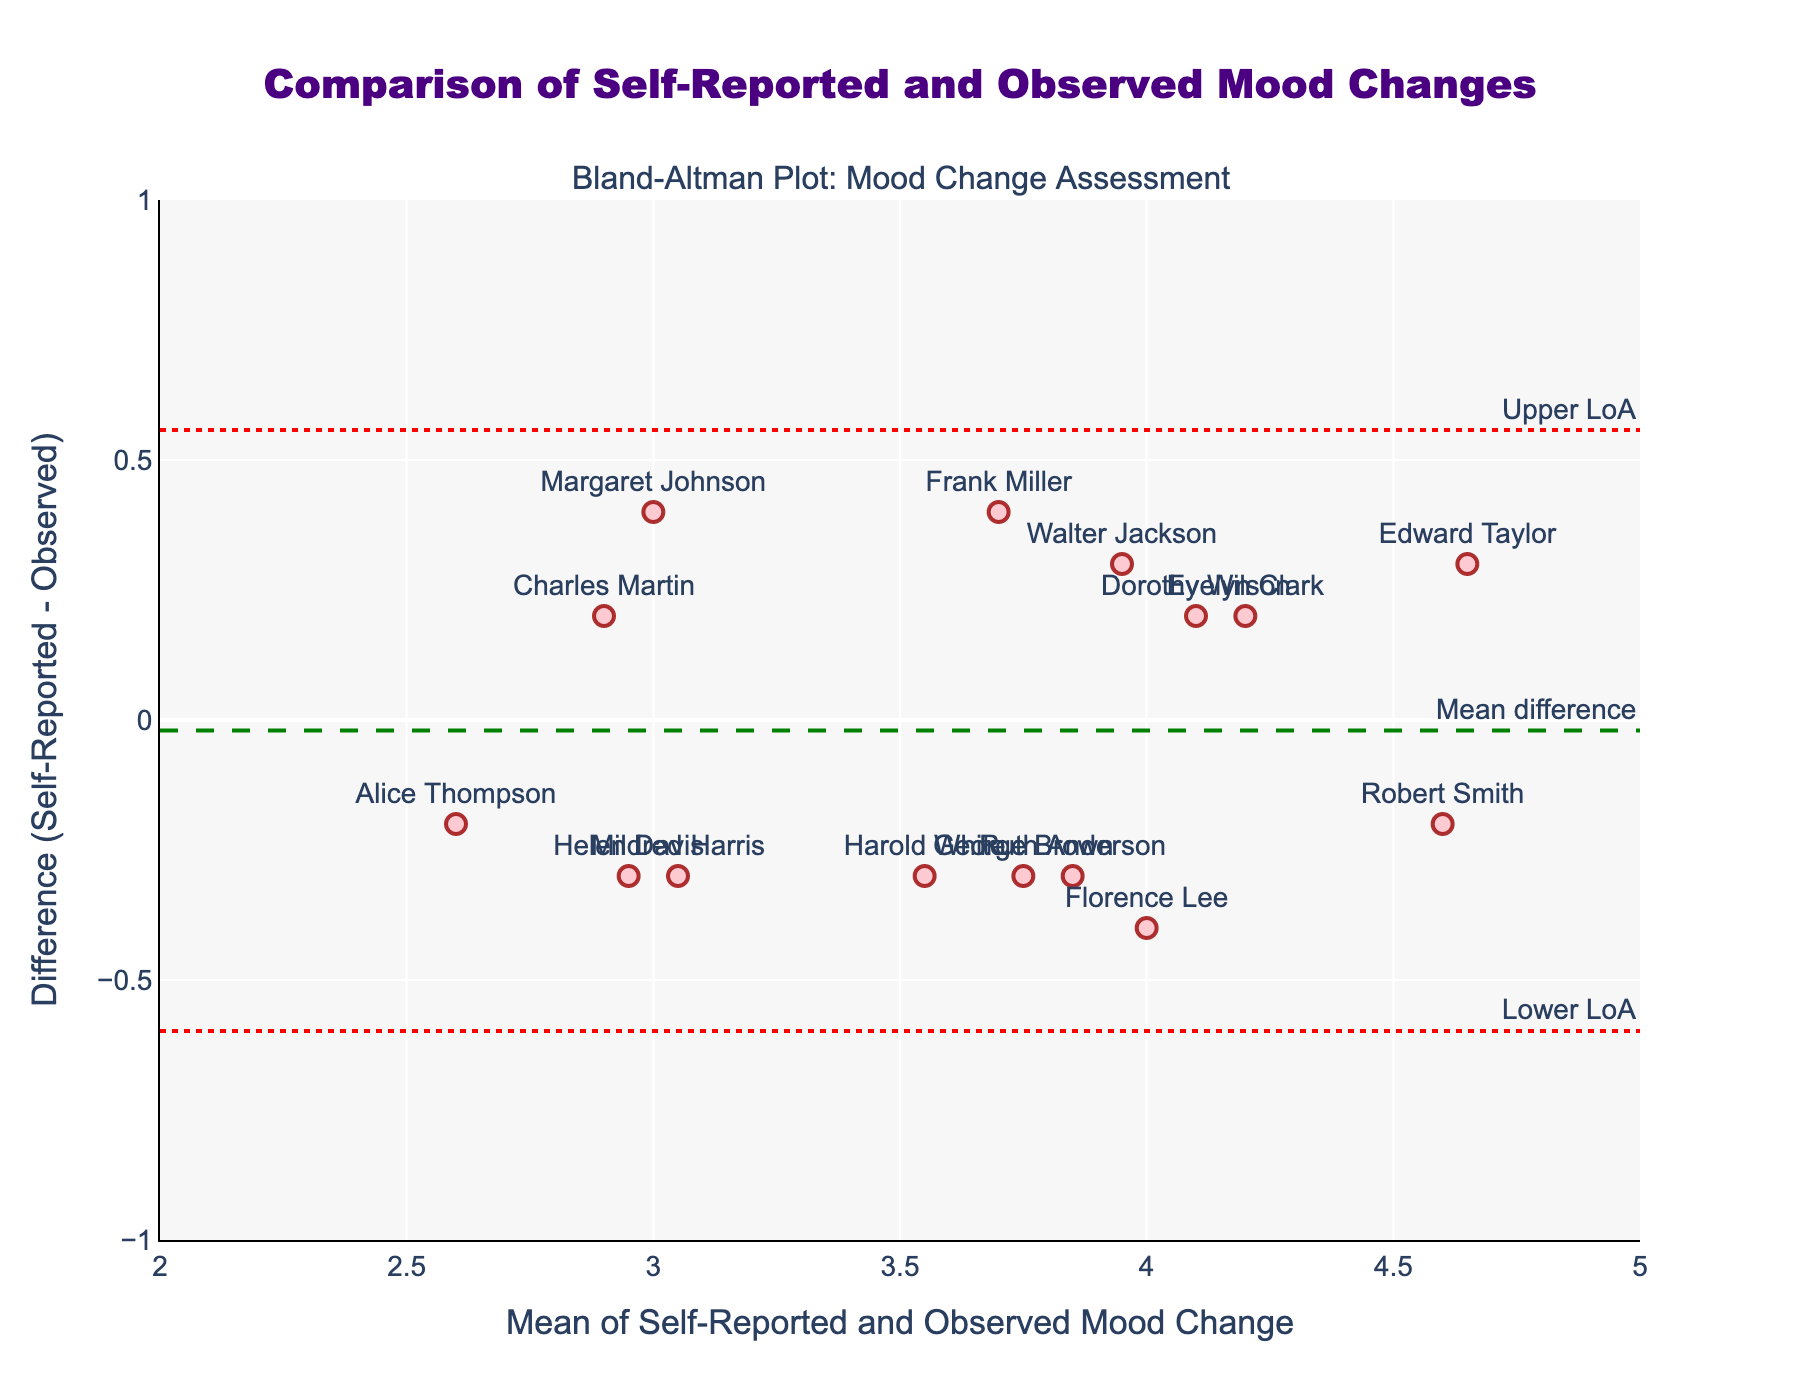what is the title of the plot? The title is written at the top center of the figure. It is designed to provide a quick overview of what the plot is representing.
Answer: Comparison of Self-Reported and Observed Mood Changes What are the axis titles in the plot? The x-axis title is visible along the bottom horizontal axis of the plot, and the y-axis title is visible along the vertical axis on the left.
Answer: Mean of Self-Reported and Observed Mood Change (x-axis), Difference (Self-Reported - Observed) (y-axis) How many data points are displayed in the plot? Each participant's data is represented by a point labeled with their name. Counting the labeled points gives the total number of data points.
Answer: 15 Which participant shows the highest mean of self-reported and observed mood changes? The mean values are plotted on the x-axis, and the participant further to the right has the highest mean.
Answer: Edward Taylor What is the range of the differences between self-reported and observed mood changes? The y-axis range provides the differences, from the maximum positive difference to the maximum negative difference. Looking at the highest and lowest plotted points on the y-axis gives the range.
Answer: -0.4 to 0.3 Describe the trend of the data points around the mean difference line. Data points are scattered around the horizontal mean difference line, indicating the average bias between self-reported and observed mood changes.
Answer: Scattered around the line What does the mean difference line represent and what is its value? The mean difference line, annotated with "Mean difference," represents the average of the differences between self-reported and observed mood changes. Its y-intercept is noted.
Answer: Green line at approximately -0.06 Which participants have a self-reported mood change much higher than their observed mood change? Looking at the data points above the mean difference line that have significant positive differences identifies these participants.
Answer: Margaret Johnson and Frank Miller Are there any participants whose self-reported mood change is almost equal to their observed mood change? Data points close to the horizontal line y=0 indicate minimal difference between self-reported and observed mood changes. Identifying the points near this line gives the answer.
Answer: Robert Smith and Charles Martin 